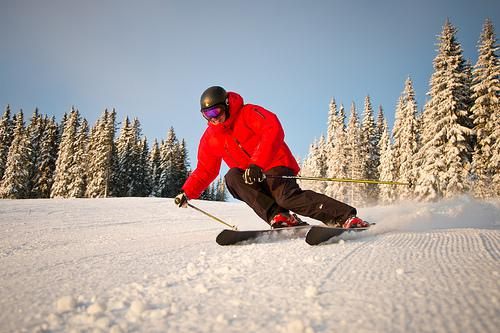Question: how many ski poles are there?
Choices:
A. One.
B. Zero.
C. Two.
D. Four.
Answer with the letter. Answer: C Question: why is the person wearing a helmet?
Choices:
A. Prevent death.
B. Avoid serious injuries.
C. Safety and protection.
D. Keep one alive.
Answer with the letter. Answer: C 